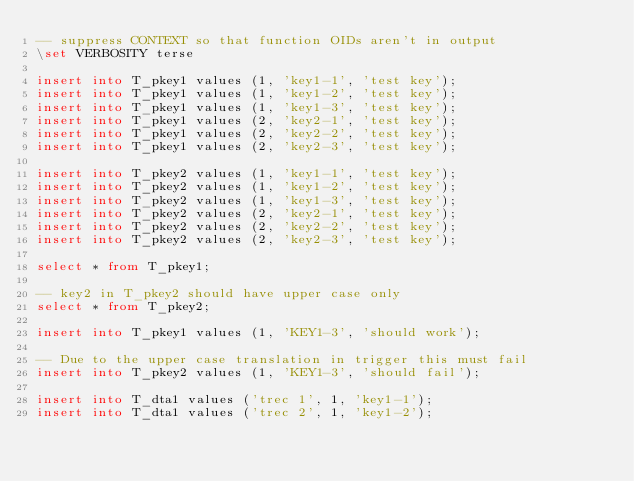Convert code to text. <code><loc_0><loc_0><loc_500><loc_500><_SQL_>-- suppress CONTEXT so that function OIDs aren't in output
\set VERBOSITY terse

insert into T_pkey1 values (1, 'key1-1', 'test key');
insert into T_pkey1 values (1, 'key1-2', 'test key');
insert into T_pkey1 values (1, 'key1-3', 'test key');
insert into T_pkey1 values (2, 'key2-1', 'test key');
insert into T_pkey1 values (2, 'key2-2', 'test key');
insert into T_pkey1 values (2, 'key2-3', 'test key');

insert into T_pkey2 values (1, 'key1-1', 'test key');
insert into T_pkey2 values (1, 'key1-2', 'test key');
insert into T_pkey2 values (1, 'key1-3', 'test key');
insert into T_pkey2 values (2, 'key2-1', 'test key');
insert into T_pkey2 values (2, 'key2-2', 'test key');
insert into T_pkey2 values (2, 'key2-3', 'test key');

select * from T_pkey1;

-- key2 in T_pkey2 should have upper case only
select * from T_pkey2;

insert into T_pkey1 values (1, 'KEY1-3', 'should work');

-- Due to the upper case translation in trigger this must fail
insert into T_pkey2 values (1, 'KEY1-3', 'should fail');

insert into T_dta1 values ('trec 1', 1, 'key1-1');
insert into T_dta1 values ('trec 2', 1, 'key1-2');</code> 